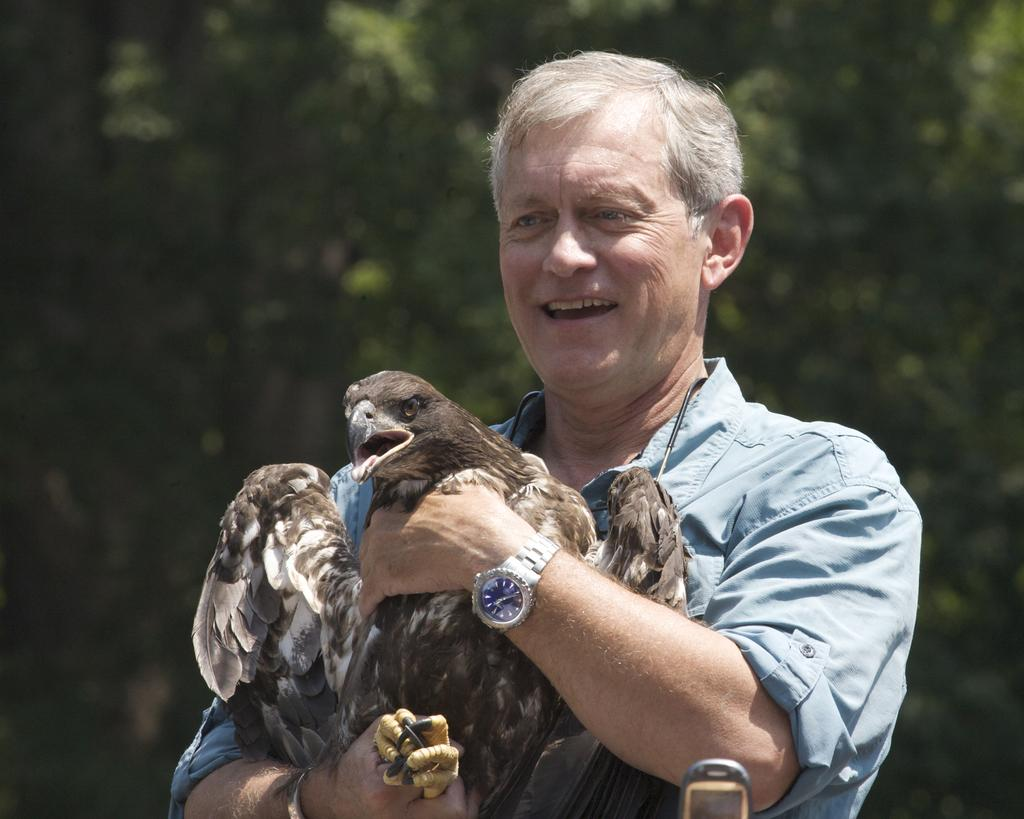What is the person in the image holding? The person is holding a bird in the image. What can be seen in the background of the image? There are trees in the background of the image. How many attempts did the person make to balance the bird on their temper? There is no mention of balancing the bird on anyone's temper in the image, as it only shows a person holding a bird. 